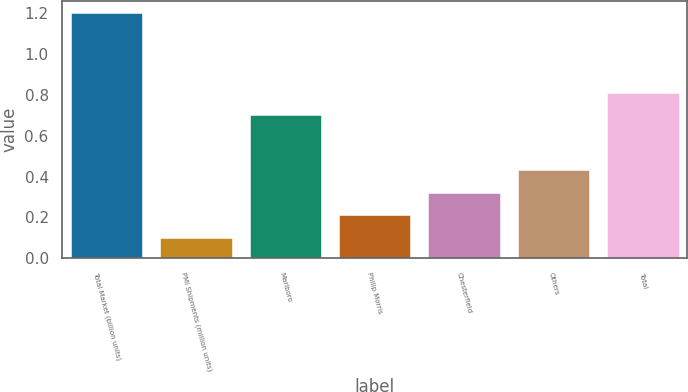<chart> <loc_0><loc_0><loc_500><loc_500><bar_chart><fcel>Total Market (billion units)<fcel>PMI Shipments (million units)<fcel>Marlboro<fcel>Philip Morris<fcel>Chesterfield<fcel>Others<fcel>Total<nl><fcel>1.2<fcel>0.1<fcel>0.7<fcel>0.21<fcel>0.32<fcel>0.43<fcel>0.81<nl></chart> 